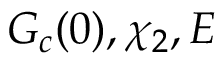Convert formula to latex. <formula><loc_0><loc_0><loc_500><loc_500>G _ { c } ( 0 ) , \chi _ { 2 } , E</formula> 